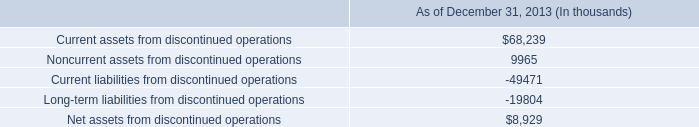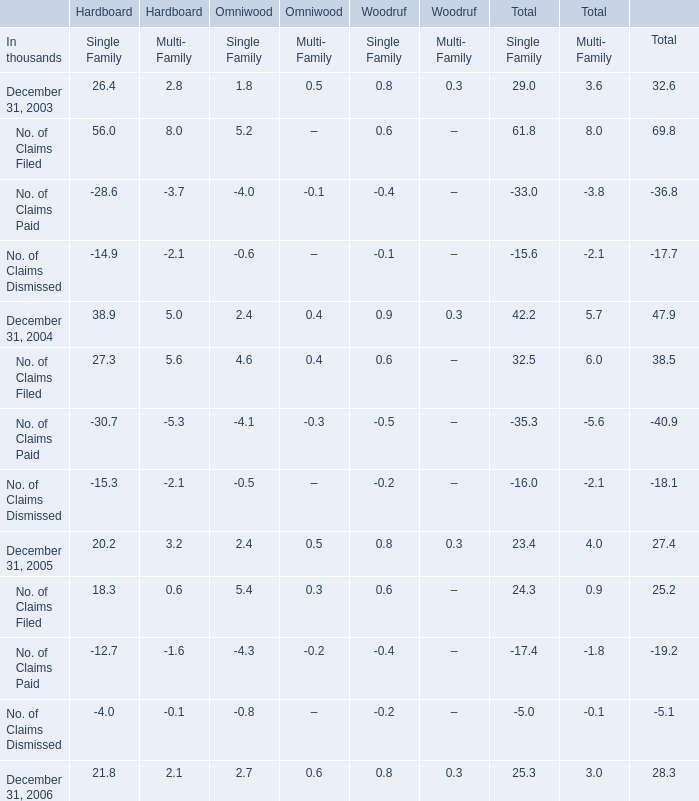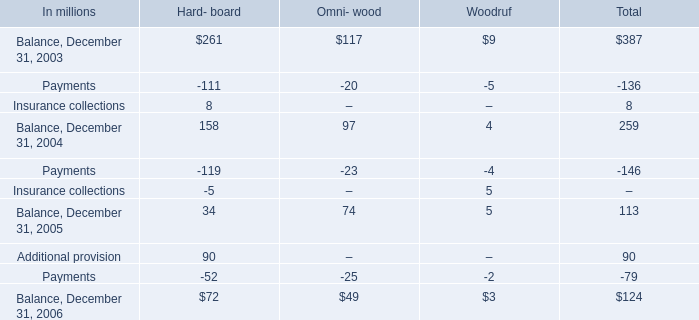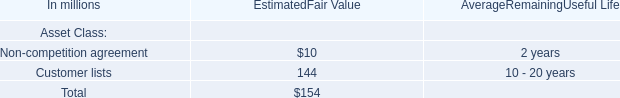What is the sum of Multi- Family of Omniwood in the range of -1 and 1 in 2003? (in thousand) 
Computations: (0.5 - 0.1)
Answer: 0.4. 